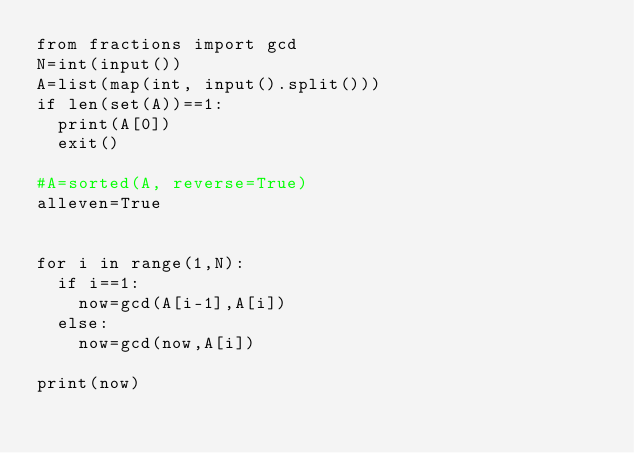Convert code to text. <code><loc_0><loc_0><loc_500><loc_500><_Python_>from fractions import gcd
N=int(input())
A=list(map(int, input().split()))
if len(set(A))==1:
  print(A[0])
  exit()
  
#A=sorted(A, reverse=True)
alleven=True


for i in range(1,N):
  if i==1:
    now=gcd(A[i-1],A[i])
  else:
    now=gcd(now,A[i])

print(now)

</code> 